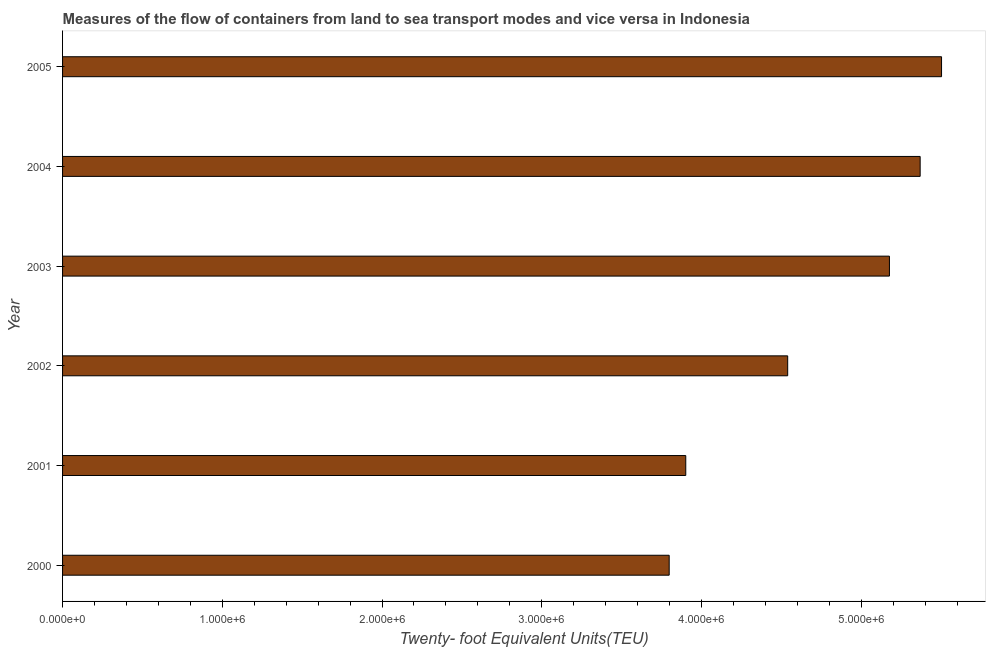What is the title of the graph?
Keep it short and to the point. Measures of the flow of containers from land to sea transport modes and vice versa in Indonesia. What is the label or title of the X-axis?
Offer a terse response. Twenty- foot Equivalent Units(TEU). What is the container port traffic in 2000?
Keep it short and to the point. 3.80e+06. Across all years, what is the maximum container port traffic?
Your response must be concise. 5.50e+06. Across all years, what is the minimum container port traffic?
Ensure brevity in your answer.  3.80e+06. What is the sum of the container port traffic?
Provide a succinct answer. 2.83e+07. What is the difference between the container port traffic in 2001 and 2005?
Ensure brevity in your answer.  -1.60e+06. What is the average container port traffic per year?
Your answer should be very brief. 4.71e+06. What is the median container port traffic?
Offer a very short reply. 4.86e+06. What is the ratio of the container port traffic in 2004 to that in 2005?
Provide a succinct answer. 0.98. What is the difference between the highest and the second highest container port traffic?
Offer a terse response. 1.34e+05. Is the sum of the container port traffic in 2000 and 2005 greater than the maximum container port traffic across all years?
Your answer should be compact. Yes. What is the difference between the highest and the lowest container port traffic?
Give a very brief answer. 1.71e+06. In how many years, is the container port traffic greater than the average container port traffic taken over all years?
Keep it short and to the point. 3. Are all the bars in the graph horizontal?
Your answer should be very brief. Yes. How many years are there in the graph?
Your answer should be compact. 6. What is the difference between two consecutive major ticks on the X-axis?
Your answer should be compact. 1.00e+06. What is the Twenty- foot Equivalent Units(TEU) in 2000?
Your answer should be compact. 3.80e+06. What is the Twenty- foot Equivalent Units(TEU) of 2001?
Your answer should be compact. 3.90e+06. What is the Twenty- foot Equivalent Units(TEU) of 2002?
Offer a terse response. 4.54e+06. What is the Twenty- foot Equivalent Units(TEU) in 2003?
Your answer should be very brief. 5.18e+06. What is the Twenty- foot Equivalent Units(TEU) in 2004?
Your answer should be compact. 5.37e+06. What is the Twenty- foot Equivalent Units(TEU) of 2005?
Your response must be concise. 5.50e+06. What is the difference between the Twenty- foot Equivalent Units(TEU) in 2000 and 2001?
Your answer should be compact. -1.04e+05. What is the difference between the Twenty- foot Equivalent Units(TEU) in 2000 and 2002?
Your answer should be very brief. -7.42e+05. What is the difference between the Twenty- foot Equivalent Units(TEU) in 2000 and 2003?
Your response must be concise. -1.38e+06. What is the difference between the Twenty- foot Equivalent Units(TEU) in 2000 and 2004?
Your response must be concise. -1.57e+06. What is the difference between the Twenty- foot Equivalent Units(TEU) in 2000 and 2005?
Keep it short and to the point. -1.71e+06. What is the difference between the Twenty- foot Equivalent Units(TEU) in 2001 and 2002?
Your answer should be very brief. -6.38e+05. What is the difference between the Twenty- foot Equivalent Units(TEU) in 2001 and 2003?
Provide a succinct answer. -1.28e+06. What is the difference between the Twenty- foot Equivalent Units(TEU) in 2001 and 2004?
Your answer should be very brief. -1.47e+06. What is the difference between the Twenty- foot Equivalent Units(TEU) in 2001 and 2005?
Your answer should be very brief. -1.60e+06. What is the difference between the Twenty- foot Equivalent Units(TEU) in 2002 and 2003?
Offer a very short reply. -6.37e+05. What is the difference between the Twenty- foot Equivalent Units(TEU) in 2002 and 2004?
Make the answer very short. -8.29e+05. What is the difference between the Twenty- foot Equivalent Units(TEU) in 2002 and 2005?
Ensure brevity in your answer.  -9.63e+05. What is the difference between the Twenty- foot Equivalent Units(TEU) in 2003 and 2004?
Your response must be concise. -1.92e+05. What is the difference between the Twenty- foot Equivalent Units(TEU) in 2003 and 2005?
Offer a terse response. -3.26e+05. What is the difference between the Twenty- foot Equivalent Units(TEU) in 2004 and 2005?
Offer a very short reply. -1.34e+05. What is the ratio of the Twenty- foot Equivalent Units(TEU) in 2000 to that in 2002?
Make the answer very short. 0.84. What is the ratio of the Twenty- foot Equivalent Units(TEU) in 2000 to that in 2003?
Make the answer very short. 0.73. What is the ratio of the Twenty- foot Equivalent Units(TEU) in 2000 to that in 2004?
Offer a very short reply. 0.71. What is the ratio of the Twenty- foot Equivalent Units(TEU) in 2000 to that in 2005?
Provide a short and direct response. 0.69. What is the ratio of the Twenty- foot Equivalent Units(TEU) in 2001 to that in 2002?
Provide a short and direct response. 0.86. What is the ratio of the Twenty- foot Equivalent Units(TEU) in 2001 to that in 2003?
Ensure brevity in your answer.  0.75. What is the ratio of the Twenty- foot Equivalent Units(TEU) in 2001 to that in 2004?
Your response must be concise. 0.73. What is the ratio of the Twenty- foot Equivalent Units(TEU) in 2001 to that in 2005?
Your answer should be compact. 0.71. What is the ratio of the Twenty- foot Equivalent Units(TEU) in 2002 to that in 2003?
Offer a terse response. 0.88. What is the ratio of the Twenty- foot Equivalent Units(TEU) in 2002 to that in 2004?
Ensure brevity in your answer.  0.85. What is the ratio of the Twenty- foot Equivalent Units(TEU) in 2002 to that in 2005?
Give a very brief answer. 0.82. What is the ratio of the Twenty- foot Equivalent Units(TEU) in 2003 to that in 2005?
Give a very brief answer. 0.94. What is the ratio of the Twenty- foot Equivalent Units(TEU) in 2004 to that in 2005?
Ensure brevity in your answer.  0.98. 